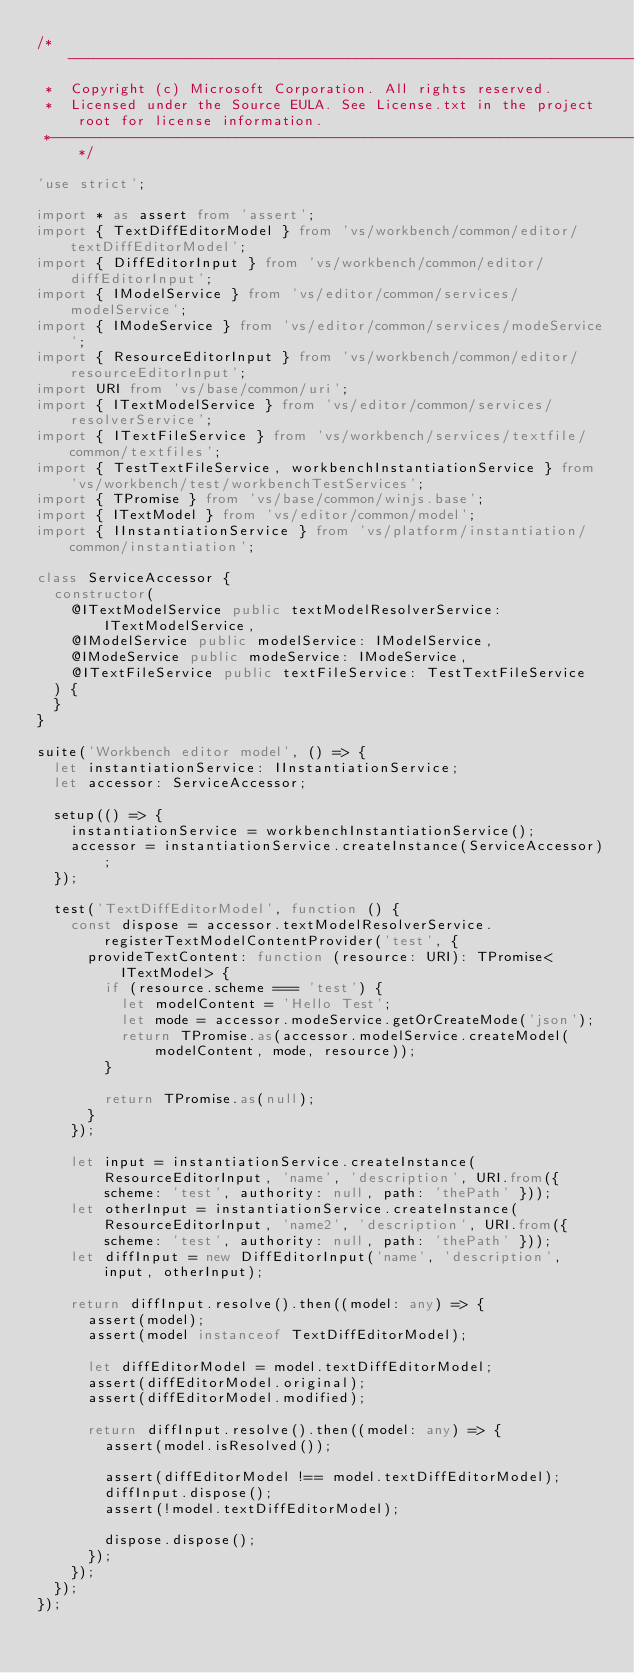Convert code to text. <code><loc_0><loc_0><loc_500><loc_500><_TypeScript_>/*---------------------------------------------------------------------------------------------
 *  Copyright (c) Microsoft Corporation. All rights reserved.
 *  Licensed under the Source EULA. See License.txt in the project root for license information.
 *--------------------------------------------------------------------------------------------*/

'use strict';

import * as assert from 'assert';
import { TextDiffEditorModel } from 'vs/workbench/common/editor/textDiffEditorModel';
import { DiffEditorInput } from 'vs/workbench/common/editor/diffEditorInput';
import { IModelService } from 'vs/editor/common/services/modelService';
import { IModeService } from 'vs/editor/common/services/modeService';
import { ResourceEditorInput } from 'vs/workbench/common/editor/resourceEditorInput';
import URI from 'vs/base/common/uri';
import { ITextModelService } from 'vs/editor/common/services/resolverService';
import { ITextFileService } from 'vs/workbench/services/textfile/common/textfiles';
import { TestTextFileService, workbenchInstantiationService } from 'vs/workbench/test/workbenchTestServices';
import { TPromise } from 'vs/base/common/winjs.base';
import { ITextModel } from 'vs/editor/common/model';
import { IInstantiationService } from 'vs/platform/instantiation/common/instantiation';

class ServiceAccessor {
	constructor(
		@ITextModelService public textModelResolverService: ITextModelService,
		@IModelService public modelService: IModelService,
		@IModeService public modeService: IModeService,
		@ITextFileService public textFileService: TestTextFileService
	) {
	}
}

suite('Workbench editor model', () => {
	let instantiationService: IInstantiationService;
	let accessor: ServiceAccessor;

	setup(() => {
		instantiationService = workbenchInstantiationService();
		accessor = instantiationService.createInstance(ServiceAccessor);
	});

	test('TextDiffEditorModel', function () {
		const dispose = accessor.textModelResolverService.registerTextModelContentProvider('test', {
			provideTextContent: function (resource: URI): TPromise<ITextModel> {
				if (resource.scheme === 'test') {
					let modelContent = 'Hello Test';
					let mode = accessor.modeService.getOrCreateMode('json');
					return TPromise.as(accessor.modelService.createModel(modelContent, mode, resource));
				}

				return TPromise.as(null);
			}
		});

		let input = instantiationService.createInstance(ResourceEditorInput, 'name', 'description', URI.from({ scheme: 'test', authority: null, path: 'thePath' }));
		let otherInput = instantiationService.createInstance(ResourceEditorInput, 'name2', 'description', URI.from({ scheme: 'test', authority: null, path: 'thePath' }));
		let diffInput = new DiffEditorInput('name', 'description', input, otherInput);

		return diffInput.resolve().then((model: any) => {
			assert(model);
			assert(model instanceof TextDiffEditorModel);

			let diffEditorModel = model.textDiffEditorModel;
			assert(diffEditorModel.original);
			assert(diffEditorModel.modified);

			return diffInput.resolve().then((model: any) => {
				assert(model.isResolved());

				assert(diffEditorModel !== model.textDiffEditorModel);
				diffInput.dispose();
				assert(!model.textDiffEditorModel);

				dispose.dispose();
			});
		});
	});
});
</code> 